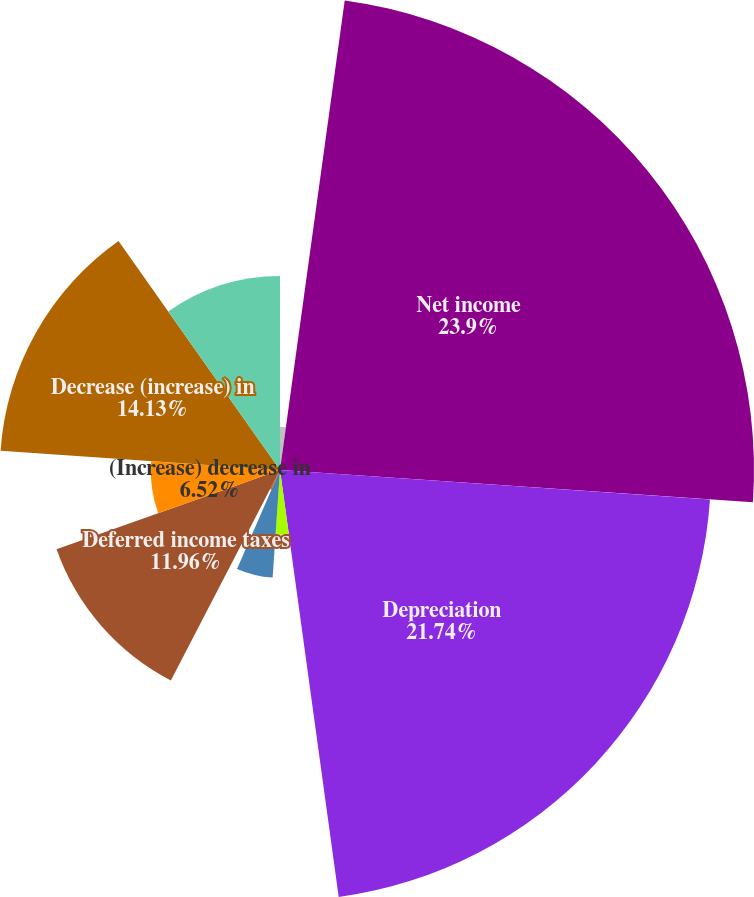Convert chart. <chart><loc_0><loc_0><loc_500><loc_500><pie_chart><fcel>(thousands)<fcel>Net income<fcel>Depreciation<fcel>Amortization of intangibles<fcel>Stock-based compensation<fcel>Other non-cash expense<fcel>Deferred income taxes<fcel>(Increase) decrease in<fcel>Decrease (increase) in<fcel>Decrease (increase) in prepaid<nl><fcel>2.18%<fcel>23.91%<fcel>21.74%<fcel>3.26%<fcel>5.44%<fcel>1.09%<fcel>11.96%<fcel>6.52%<fcel>14.13%<fcel>9.78%<nl></chart> 